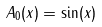<formula> <loc_0><loc_0><loc_500><loc_500>A _ { 0 } ( x ) = \sin ( x )</formula> 